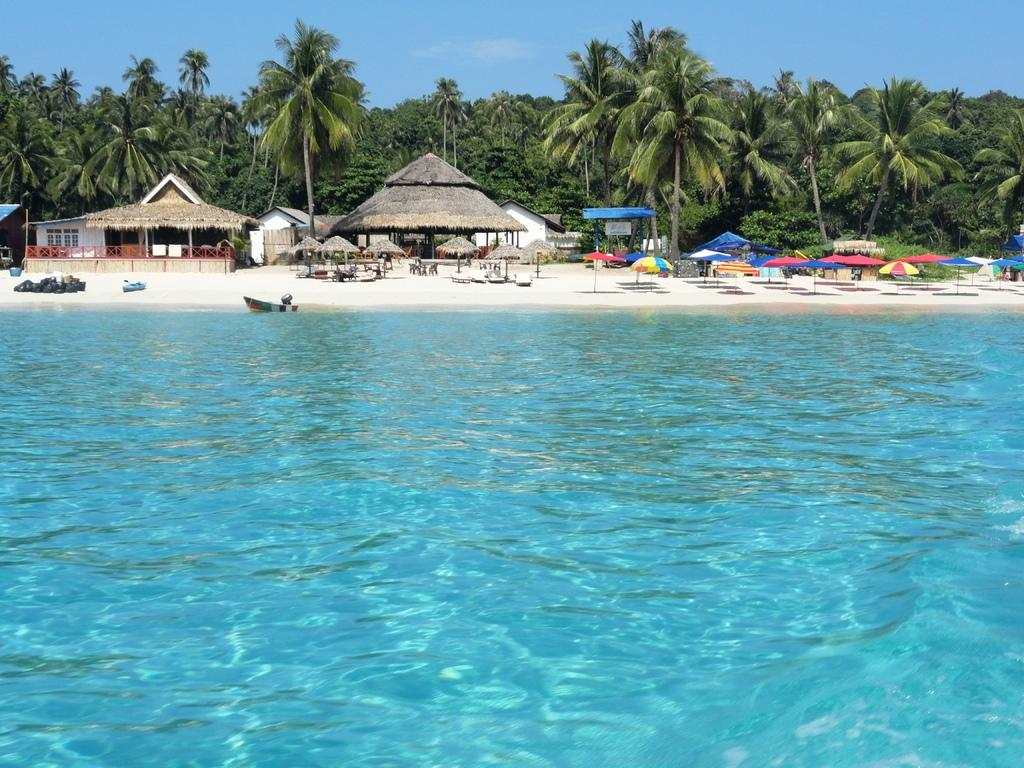What type of structures can be seen in the image? There are sheds in the image. What other natural elements are present in the image? There are trees in the image. What objects are available for shade or protection from the elements? There are umbrellas in the image. What type of seating is available in the image? There are benches in the image. What is on the water in the image? There is a boat on the water in the image. What type of leather material is used to make the sponge in the image? There is no sponge or leather material present in the image. What decision was made by the trees in the image? Trees do not make decisions; they are inanimate objects. 